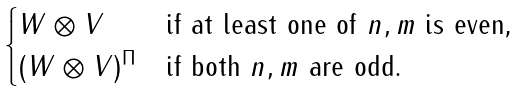Convert formula to latex. <formula><loc_0><loc_0><loc_500><loc_500>\begin{cases} W \otimes V & \text {if at least one of $n,m$ is even,} \\ ( W \otimes V ) ^ { \Pi } & \text {if both $n,m$ are odd.} \end{cases}</formula> 